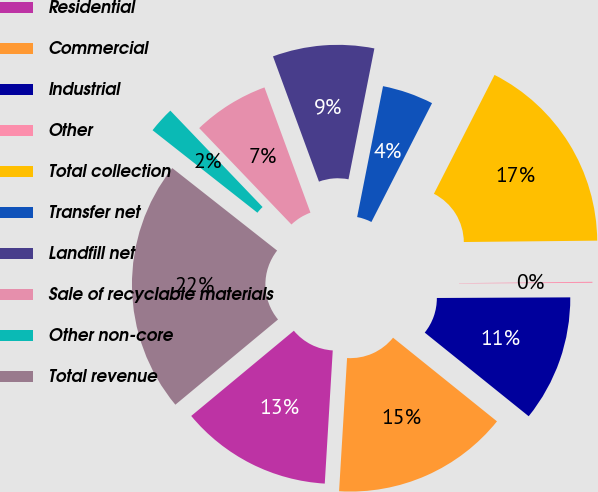<chart> <loc_0><loc_0><loc_500><loc_500><pie_chart><fcel>Residential<fcel>Commercial<fcel>Industrial<fcel>Other<fcel>Total collection<fcel>Transfer net<fcel>Landfill net<fcel>Sale of recyclable materials<fcel>Other non-core<fcel>Total revenue<nl><fcel>13.02%<fcel>15.17%<fcel>10.86%<fcel>0.09%<fcel>17.33%<fcel>4.4%<fcel>8.71%<fcel>6.55%<fcel>2.24%<fcel>21.64%<nl></chart> 